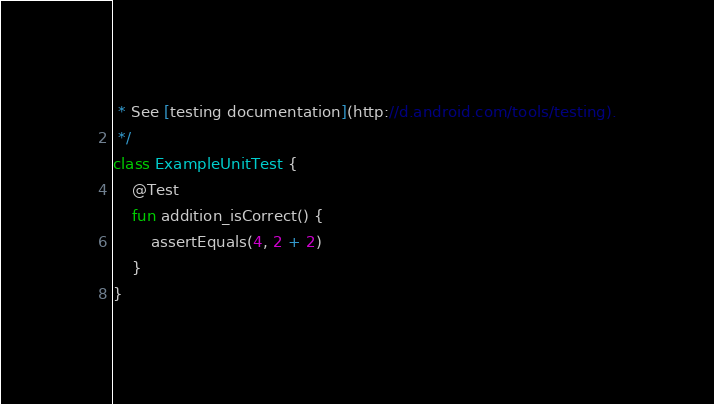<code> <loc_0><loc_0><loc_500><loc_500><_Kotlin_> * See [testing documentation](http://d.android.com/tools/testing).
 */
class ExampleUnitTest {
    @Test
    fun addition_isCorrect() {
        assertEquals(4, 2 + 2)
    }
}</code> 